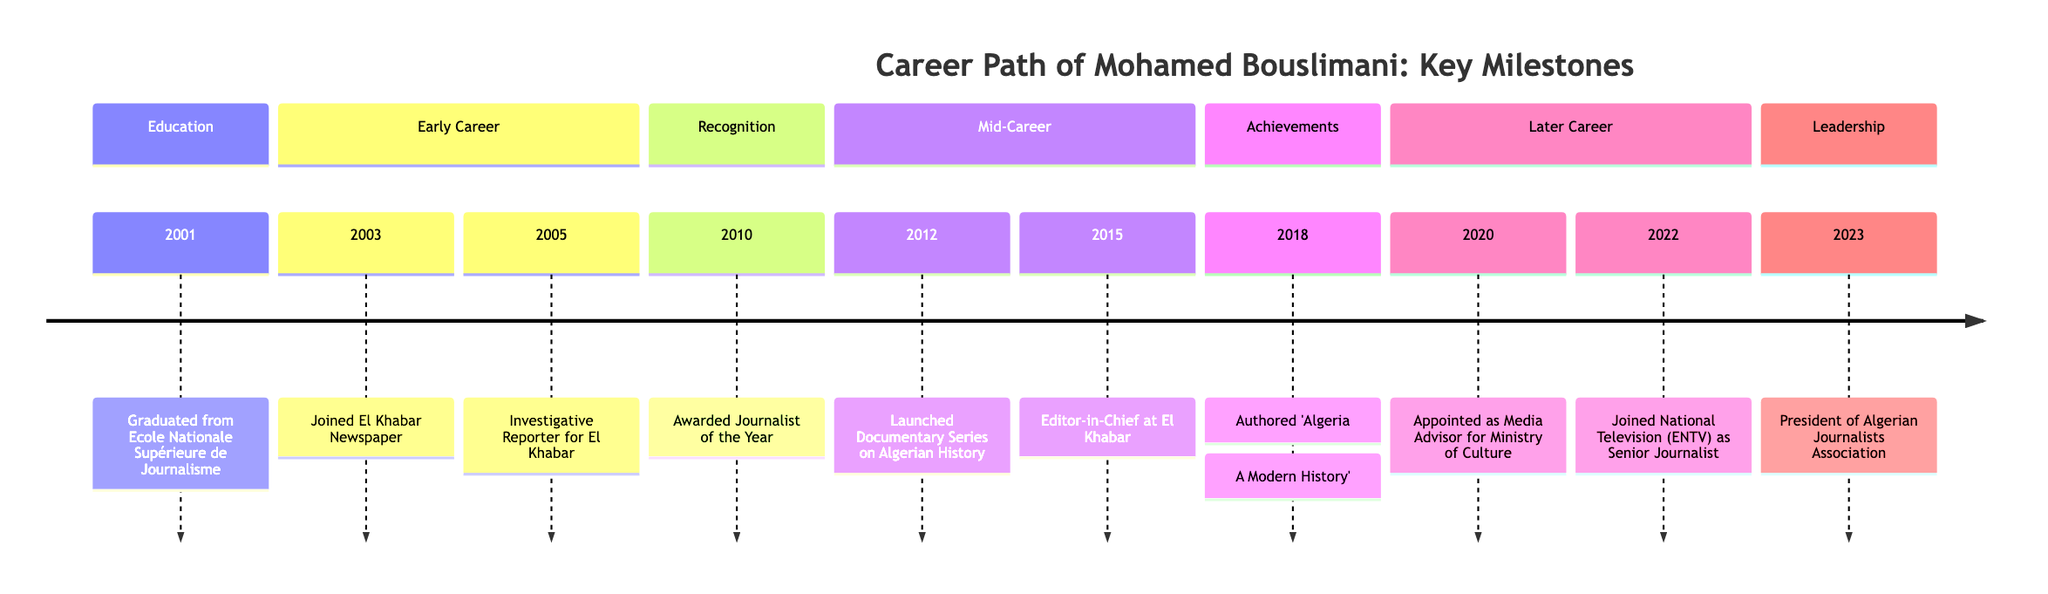What year did Mohamed Bouslimani graduate? According to the diagram in the Education section, Mohamed Bouslimani graduated from Ecole Nationale Supérieure de Journalisme in the year 2001.
Answer: 2001 How many years after joining El Khabar Newspaper did he become an Investigative Reporter? The timeline indicates that he joined El Khabar Newspaper in 2003 and became an Investigative Reporter in 2005, which is a span of 2 years.
Answer: 2 years What notable recognition did Bouslimani receive in 2010? The diagram shows that in 2010, he was awarded Journalist of the Year, which is a significant recognition in his career.
Answer: Journalist of the Year When did he launch a documentary series on Algerian history? The diagram states that he launched a Documentary Series on Algerian History in 2012, providing specific time information on this milestone in his career.
Answer: 2012 What position did he hold at El Khabar in 2015? According to the diagram, in 2015 he was the Editor-in-Chief at El Khabar, indicating his leadership role at that time.
Answer: Editor-in-Chief How many years passed from the publication of 'Algeria: A Modern History' to his appointment as Media Advisor for the Ministry of Culture? The timeline indicates that he authored 'Algeria: A Modern History' in 2018 and became Media Advisor for the Ministry of Culture in 2020, which is a gap of 2 years.
Answer: 2 years Which position marks the peak of his career by 2023? By 2023, the diagram indicates that he became the President of the Algerian Journalists Association, which is a significant leadership position and a culminating step in his career.
Answer: President of Algerian Journalists Association What was a significant achievement in his later career? According to the diagram, a significant achievement in his later career was joining National Television (ENTV) as a Senior Journalist in 2022, marking a notable progression in his career path.
Answer: Senior Journalist What major milestone did he achieve in 2018? The diagram highlights 2018 as the year he authored the book 'Algeria: A Modern History', which is identified as a key milestone in his career.
Answer: Authored 'Algeria: A Modern History' 